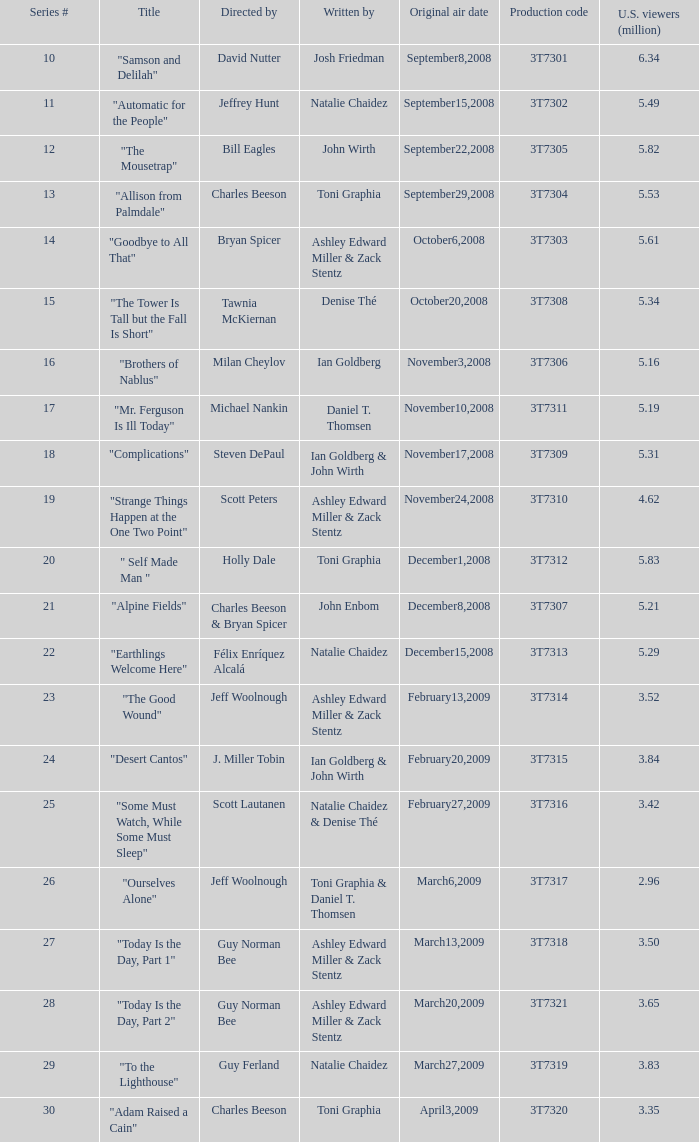Which episode number drew in 3.84 million viewers in the U.S.? 24.0. Can you parse all the data within this table? {'header': ['Series #', 'Title', 'Directed by', 'Written by', 'Original air date', 'Production code', 'U.S. viewers (million)'], 'rows': [['10', '"Samson and Delilah"', 'David Nutter', 'Josh Friedman', 'September8,2008', '3T7301', '6.34'], ['11', '"Automatic for the People"', 'Jeffrey Hunt', 'Natalie Chaidez', 'September15,2008', '3T7302', '5.49'], ['12', '"The Mousetrap"', 'Bill Eagles', 'John Wirth', 'September22,2008', '3T7305', '5.82'], ['13', '"Allison from Palmdale"', 'Charles Beeson', 'Toni Graphia', 'September29,2008', '3T7304', '5.53'], ['14', '"Goodbye to All That"', 'Bryan Spicer', 'Ashley Edward Miller & Zack Stentz', 'October6,2008', '3T7303', '5.61'], ['15', '"The Tower Is Tall but the Fall Is Short"', 'Tawnia McKiernan', 'Denise Thé', 'October20,2008', '3T7308', '5.34'], ['16', '"Brothers of Nablus"', 'Milan Cheylov', 'Ian Goldberg', 'November3,2008', '3T7306', '5.16'], ['17', '"Mr. Ferguson Is Ill Today"', 'Michael Nankin', 'Daniel T. Thomsen', 'November10,2008', '3T7311', '5.19'], ['18', '"Complications"', 'Steven DePaul', 'Ian Goldberg & John Wirth', 'November17,2008', '3T7309', '5.31'], ['19', '"Strange Things Happen at the One Two Point"', 'Scott Peters', 'Ashley Edward Miller & Zack Stentz', 'November24,2008', '3T7310', '4.62'], ['20', '" Self Made Man "', 'Holly Dale', 'Toni Graphia', 'December1,2008', '3T7312', '5.83'], ['21', '"Alpine Fields"', 'Charles Beeson & Bryan Spicer', 'John Enbom', 'December8,2008', '3T7307', '5.21'], ['22', '"Earthlings Welcome Here"', 'Félix Enríquez Alcalá', 'Natalie Chaidez', 'December15,2008', '3T7313', '5.29'], ['23', '"The Good Wound"', 'Jeff Woolnough', 'Ashley Edward Miller & Zack Stentz', 'February13,2009', '3T7314', '3.52'], ['24', '"Desert Cantos"', 'J. Miller Tobin', 'Ian Goldberg & John Wirth', 'February20,2009', '3T7315', '3.84'], ['25', '"Some Must Watch, While Some Must Sleep"', 'Scott Lautanen', 'Natalie Chaidez & Denise Thé', 'February27,2009', '3T7316', '3.42'], ['26', '"Ourselves Alone"', 'Jeff Woolnough', 'Toni Graphia & Daniel T. Thomsen', 'March6,2009', '3T7317', '2.96'], ['27', '"Today Is the Day, Part 1"', 'Guy Norman Bee', 'Ashley Edward Miller & Zack Stentz', 'March13,2009', '3T7318', '3.50'], ['28', '"Today Is the Day, Part 2"', 'Guy Norman Bee', 'Ashley Edward Miller & Zack Stentz', 'March20,2009', '3T7321', '3.65'], ['29', '"To the Lighthouse"', 'Guy Ferland', 'Natalie Chaidez', 'March27,2009', '3T7319', '3.83'], ['30', '"Adam Raised a Cain"', 'Charles Beeson', 'Toni Graphia', 'April3,2009', '3T7320', '3.35']]} 